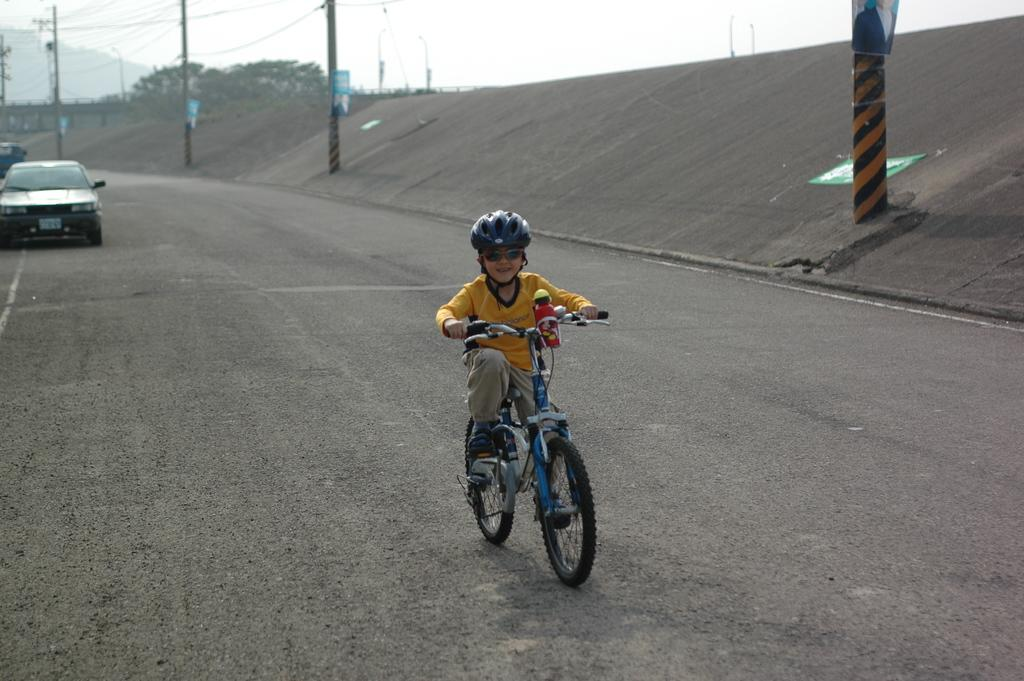Who is the main subject in the image? There is a boy in the image. What is the boy doing in the image? The boy is cycling a cycle. What safety gear is the boy wearing? The boy is wearing a helmet. What additional accessory is the boy wearing? The boy is wearing shades. What can be seen in the background of the image? There is a car, poles, and trees in the background of the image. How does the boy plan to increase his trade in the image? There is no indication in the image that the boy is involved in any trade or business activities. 